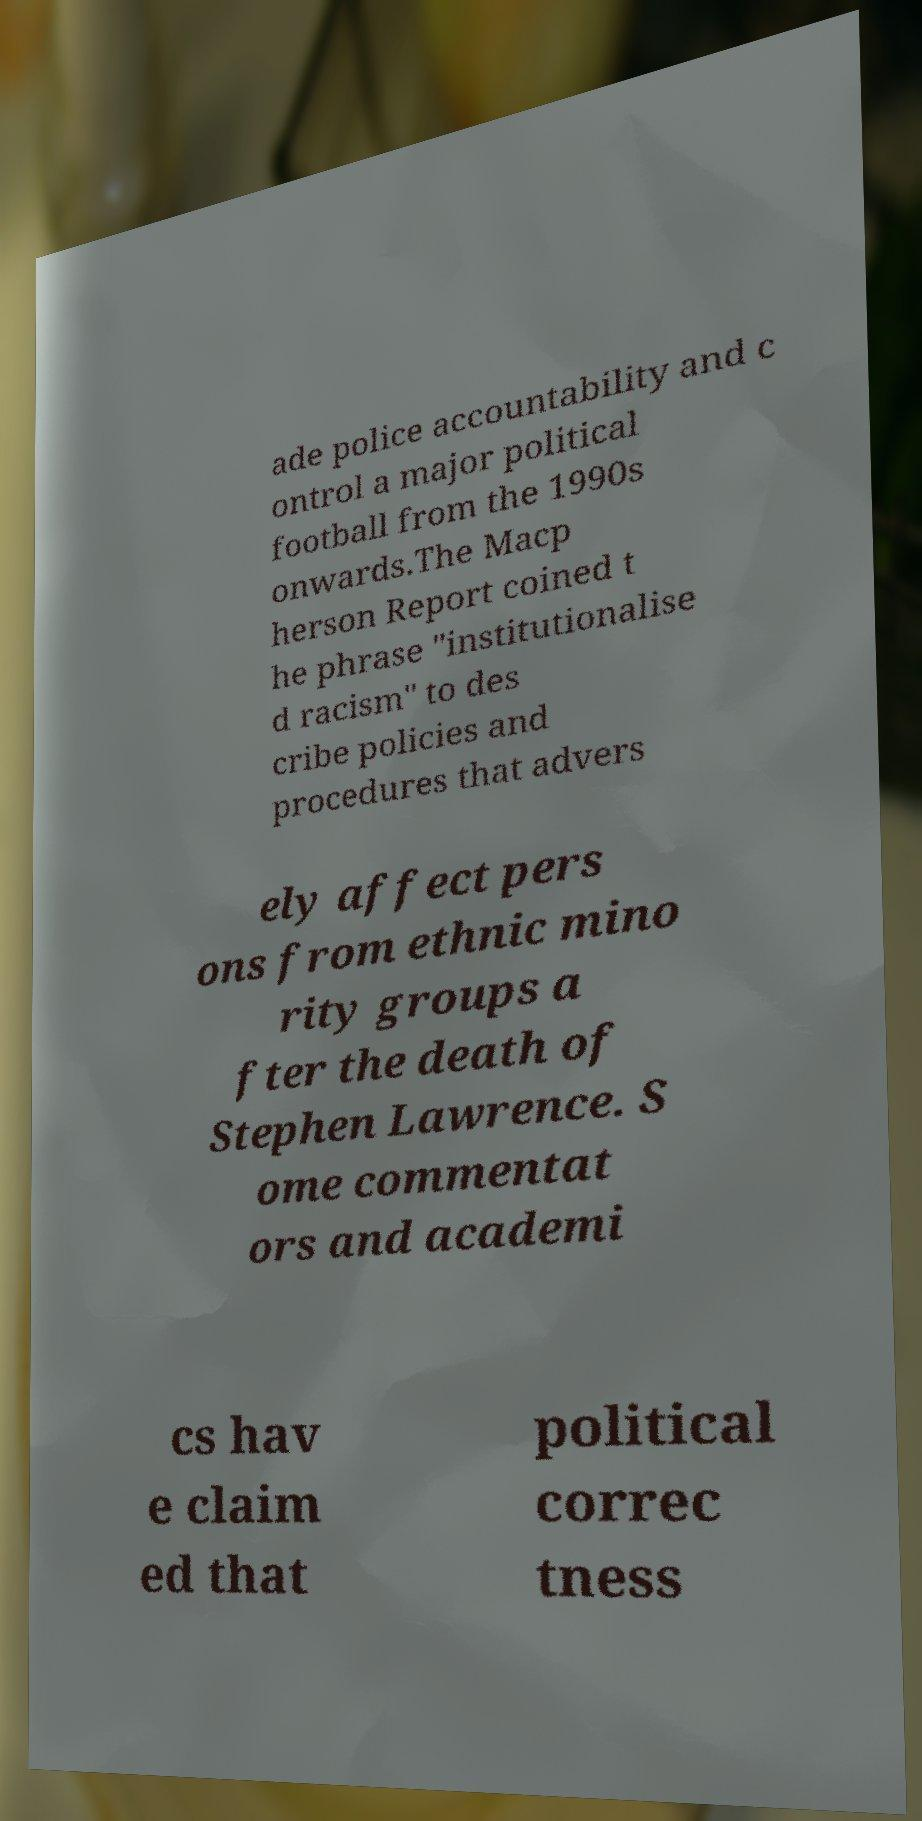There's text embedded in this image that I need extracted. Can you transcribe it verbatim? ade police accountability and c ontrol a major political football from the 1990s onwards.The Macp herson Report coined t he phrase "institutionalise d racism" to des cribe policies and procedures that advers ely affect pers ons from ethnic mino rity groups a fter the death of Stephen Lawrence. S ome commentat ors and academi cs hav e claim ed that political correc tness 